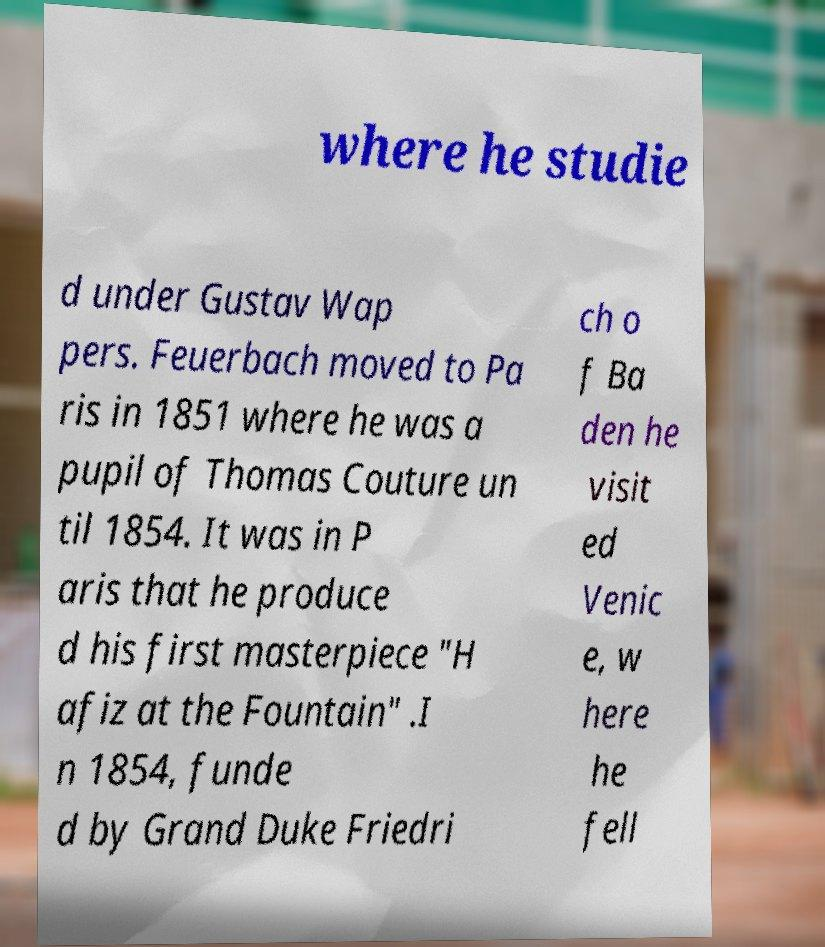Can you accurately transcribe the text from the provided image for me? where he studie d under Gustav Wap pers. Feuerbach moved to Pa ris in 1851 where he was a pupil of Thomas Couture un til 1854. It was in P aris that he produce d his first masterpiece "H afiz at the Fountain" .I n 1854, funde d by Grand Duke Friedri ch o f Ba den he visit ed Venic e, w here he fell 